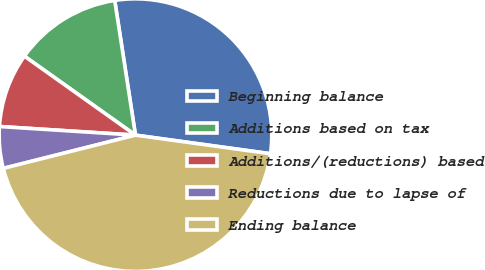Convert chart to OTSL. <chart><loc_0><loc_0><loc_500><loc_500><pie_chart><fcel>Beginning balance<fcel>Additions based on tax<fcel>Additions/(reductions) based<fcel>Reductions due to lapse of<fcel>Ending balance<nl><fcel>29.61%<fcel>12.73%<fcel>8.83%<fcel>4.93%<fcel>43.9%<nl></chart> 